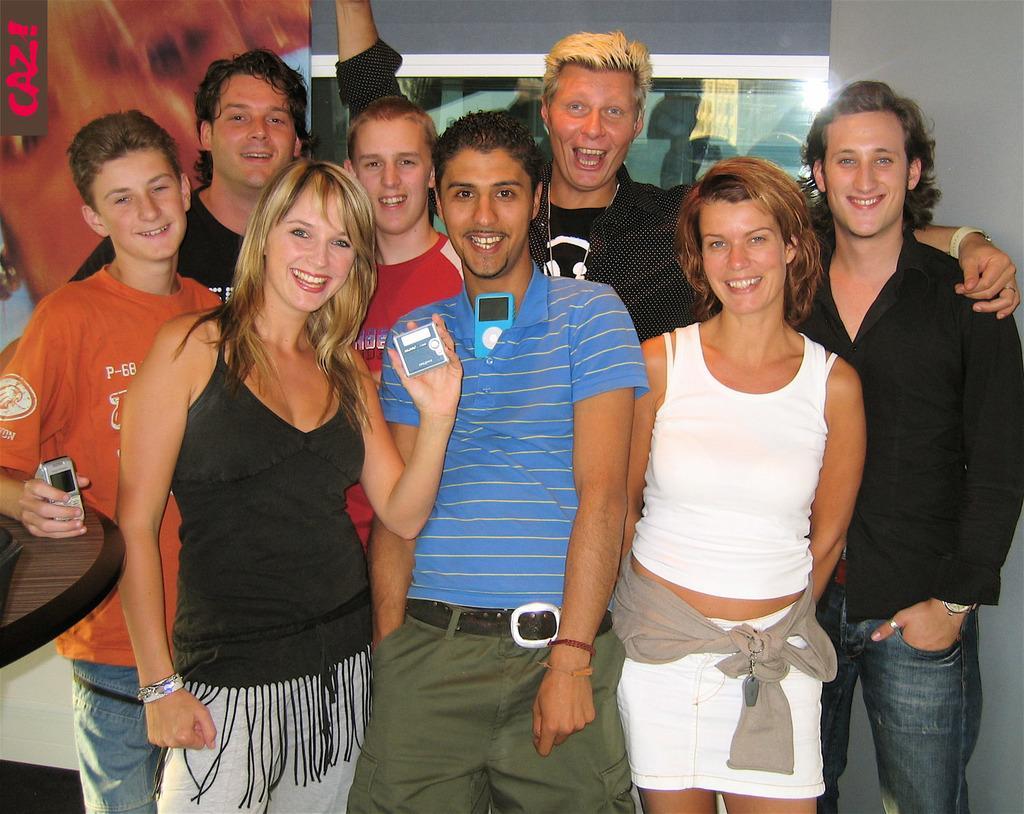Could you give a brief overview of what you see in this image? In the image there are few people standing. There is a lady holding an object in the hand. Beside her there is a man with mobile on him. Behind the lady there is a man holding a mobile and kept a hand on the table. Behind them there is a poster and also there is a window. 